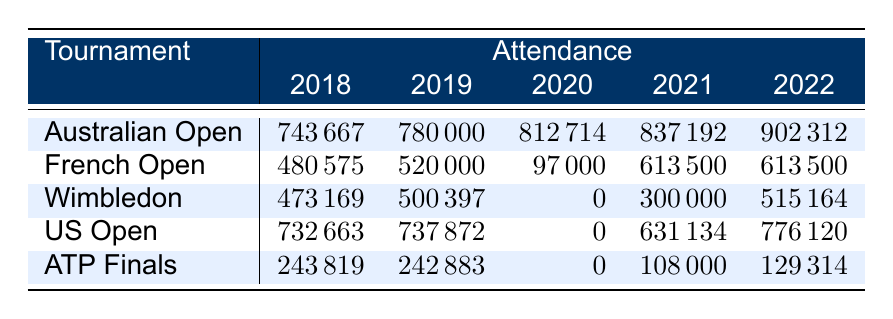What was the attendance for the Australian Open in 2022? Referring to the table, the attendance figure for the Australian Open in 2022 is directly listed as 902312.
Answer: 902312 What was the lowest recorded attendance across all tournaments in 2020? In 2020, the attendance figures are 812714 for the Australian Open, 97000 for the French Open, 0 for Wimbledon, 0 for the US Open, and 0 for the ATP Finals. The lowest among these is 0, which occurred in Wimbledon, US Open, and ATP Finals.
Answer: 0 What is the average attendance for the French Open over the years? To find the average attendance for the French Open, we sum the attendance figures (480575 + 520000 + 97000 + 613500 + 613500) = 1982575. There are 5 data points, so the average is 1982575 / 5 = 396515.
Answer: 396515 Which tournament had the highest attendance in 2021? In 2021, the attendance figures were 837192 for the Australian Open, 613500 for the French Open, 300000 for Wimbledon, 631134 for the US Open, and 108000 for the ATP Finals. The highest figure is 837192, which belongs to the Australian Open.
Answer: Australian Open What was the difference in attendance between the US Open in 2021 and 2022? The attendance for the US Open in 2021 was 631134, and in 2022 it was 776120. The difference is calculated as 776120 - 631134 = 144986.
Answer: 144986 Was there any attendance recorded for Wimbledon in 2020? The table indicates that the attendance for Wimbledon in 2020 is 0, which suggests that no attendance was recorded for that year.
Answer: No What was the total attendance for all tournaments in 2019? To find the total attendance in 2019, we add the figures for each tournament: 780000 (Australian Open) + 520000 (French Open) + 500397 (Wimbledon) + 737872 (US Open) + 242883 (ATP Finals) = 2781152.
Answer: 2781152 What was the trend in attendance for the ATP Finals from 2018 to 2022? The attendance figures for the ATP Finals are: 243819 in 2018, 242883 in 2019, 0 in 2020, 108000 in 2021, and 129314 in 2022. There is a significant drop in 2020 to 0, followed by a gradual increase in 2021 and 2022.
Answer: Decreasing then increasing Which tournament had consistent attendance figures across the years? Looking at the table, the ATP Finals shows a notable inconsistency, while the French Open had attendance figures of 480575, 520000, 97000, 613500, 613500; the attendance fluctuated significantly. Therefore, none of the tournaments had consistent figures across all years.
Answer: None 